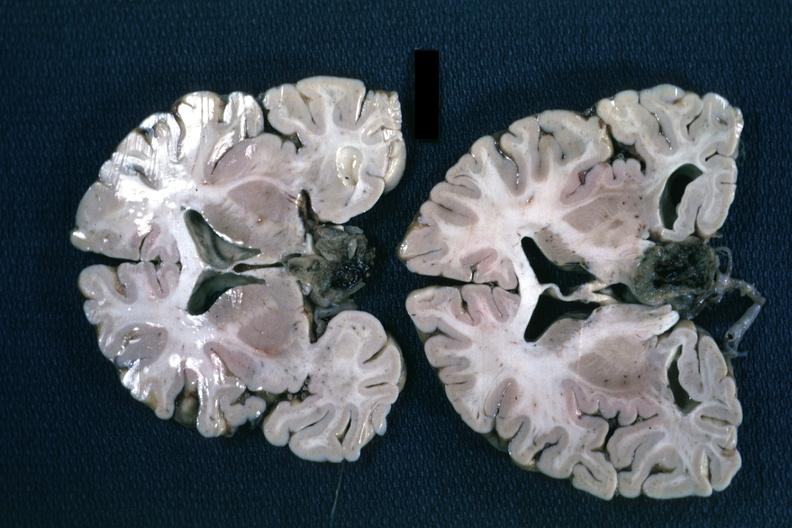does this image show fixed tissue coronal sections hemispheres with large inferior lesion?
Answer the question using a single word or phrase. Yes 